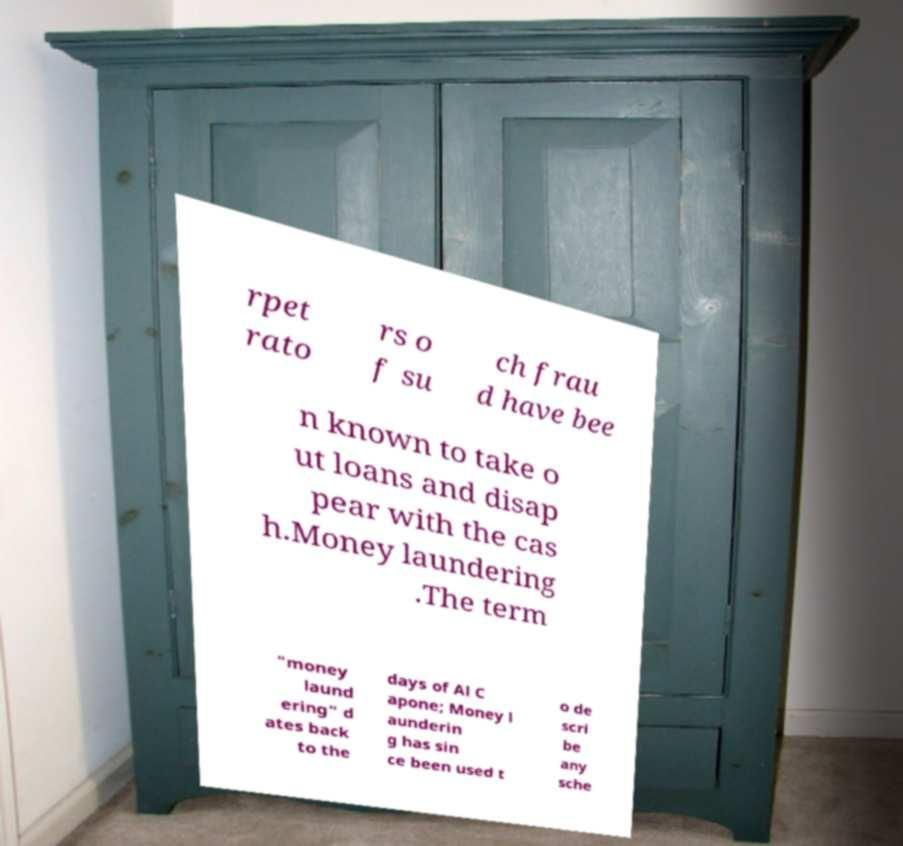There's text embedded in this image that I need extracted. Can you transcribe it verbatim? rpet rato rs o f su ch frau d have bee n known to take o ut loans and disap pear with the cas h.Money laundering .The term "money laund ering" d ates back to the days of Al C apone; Money l aunderin g has sin ce been used t o de scri be any sche 